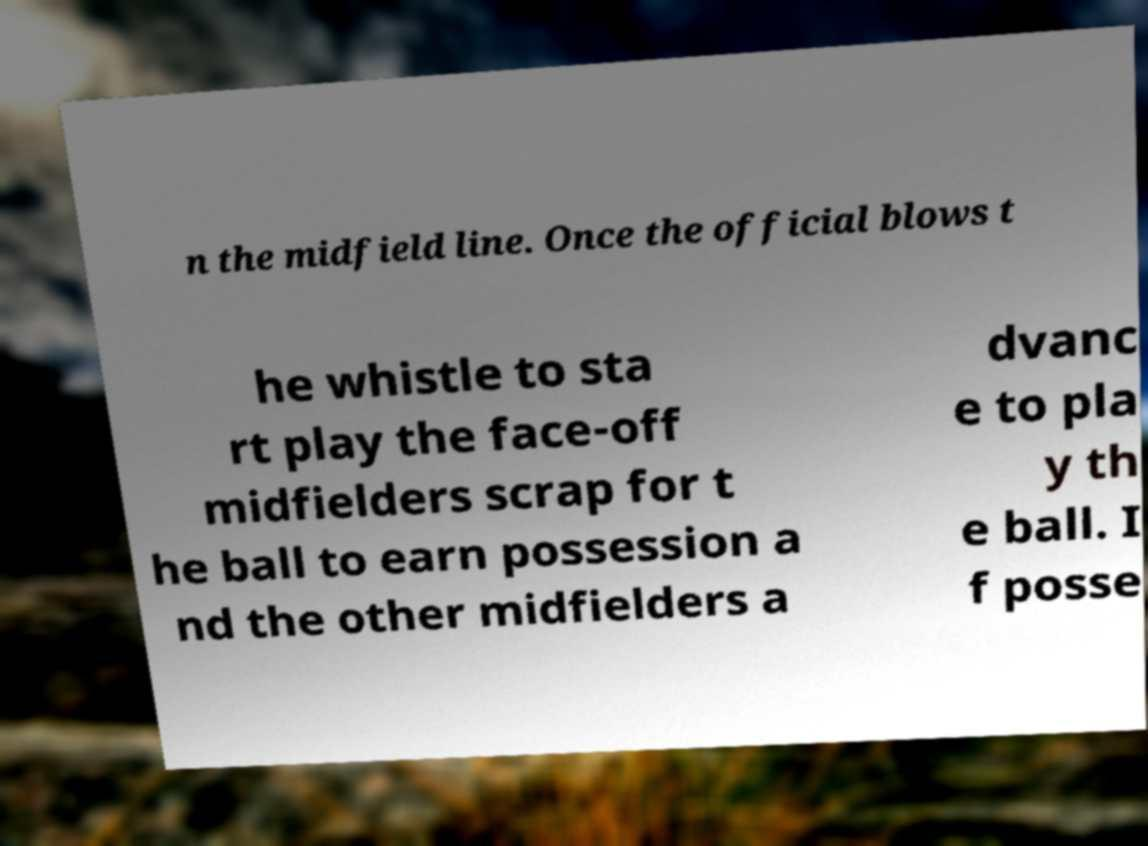For documentation purposes, I need the text within this image transcribed. Could you provide that? n the midfield line. Once the official blows t he whistle to sta rt play the face-off midfielders scrap for t he ball to earn possession a nd the other midfielders a dvanc e to pla y th e ball. I f posse 